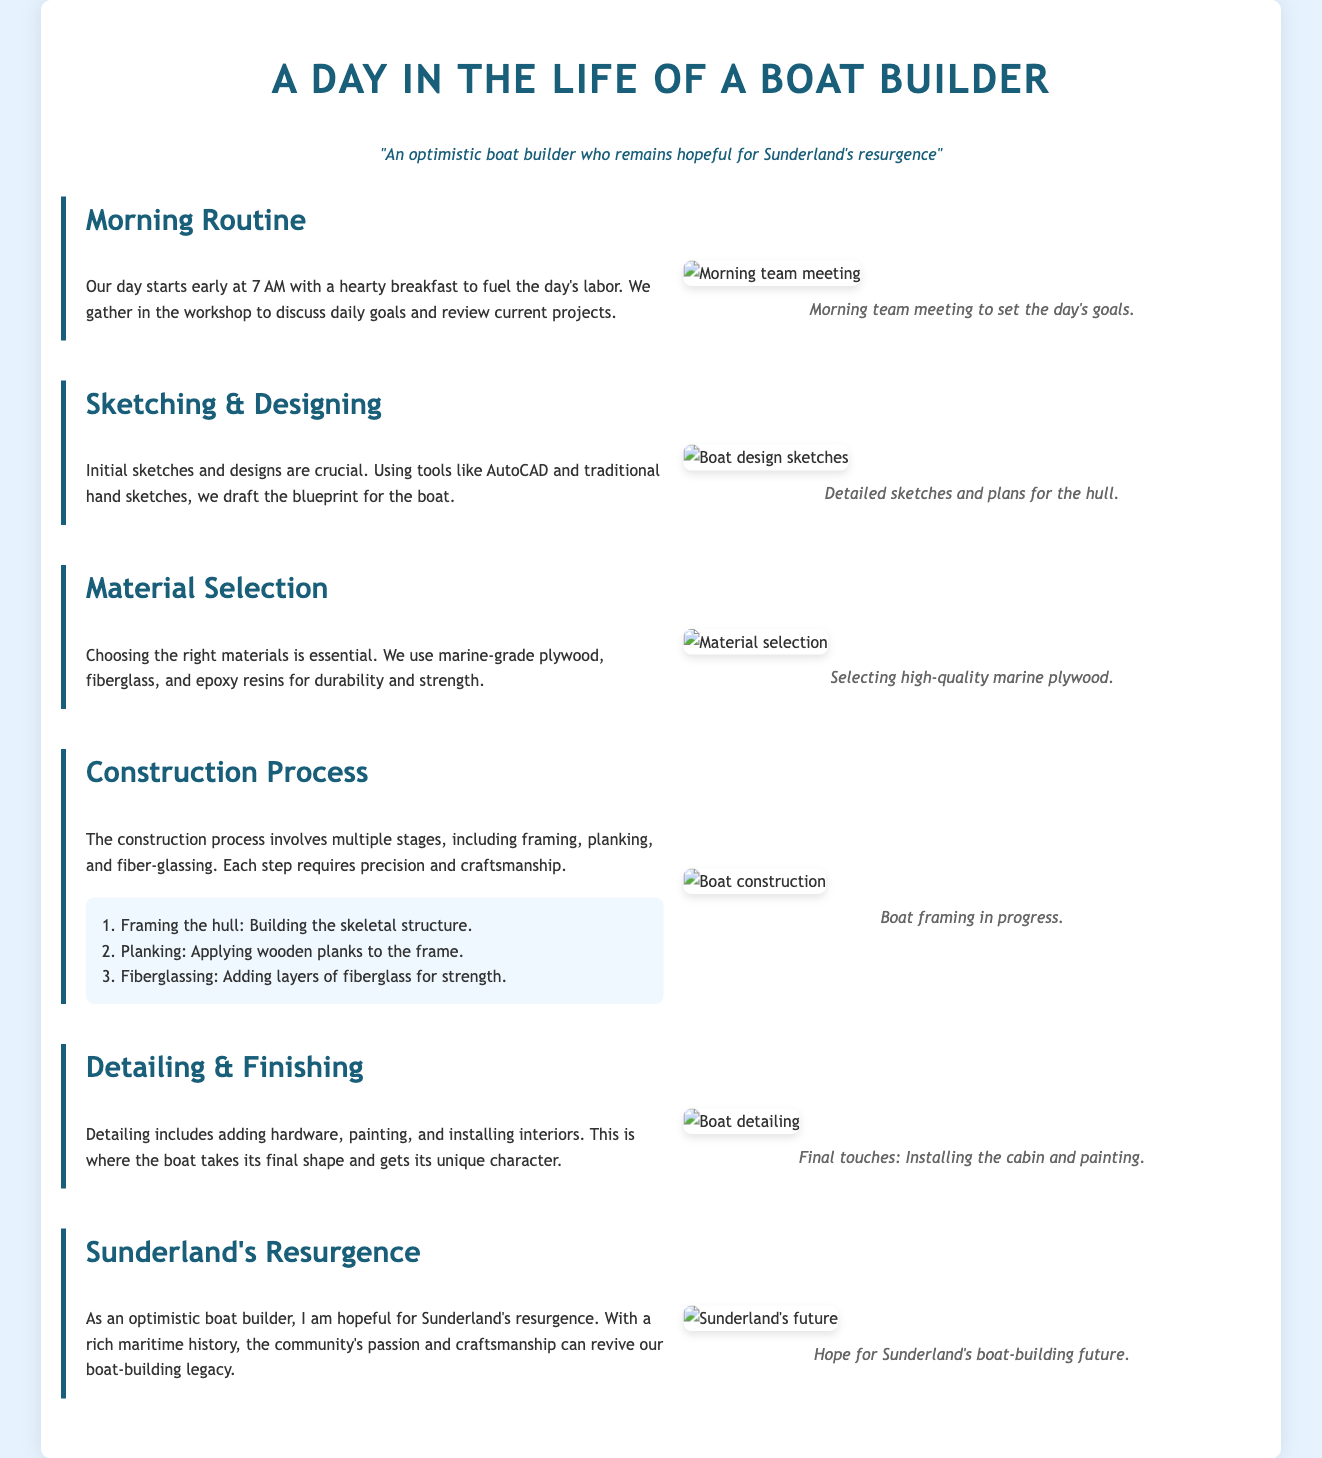What time does the day start for boat builders? The document states that the day starts at 7 AM with breakfast.
Answer: 7 AM What tools are mentioned for sketching and designing? The document lists tools like AutoCAD and traditional hand sketches for drafting.
Answer: AutoCAD and hand sketches What type of plywood is selected for boat building? The document specifies that marine-grade plywood is used.
Answer: Marine-grade plywood What are the three main steps in the construction process? The construction process includes framing, planking, and fiberglassing.
Answer: Framing, planking, fiberglassing What is added during the detailing phase? The detailing phase includes adding hardware, painting, and installing interiors.
Answer: Hardware, painting, interiors How does the boat builder feel about Sunderland's future? The document mentions that the boat builder is optimistic about Sunderland's resurgence.
Answer: Optimistic How many stages are mentioned in the construction process? The document outlines three stages in the construction process.
Answer: Three stages What is the color theme of the document? The document features a background color of light blue and text in darker shades of blue for headings.
Answer: Light blue background What does the caption say for the construction process image? The caption for the construction process image states that it shows 'Boat framing in progress.'
Answer: Boat framing in progress 